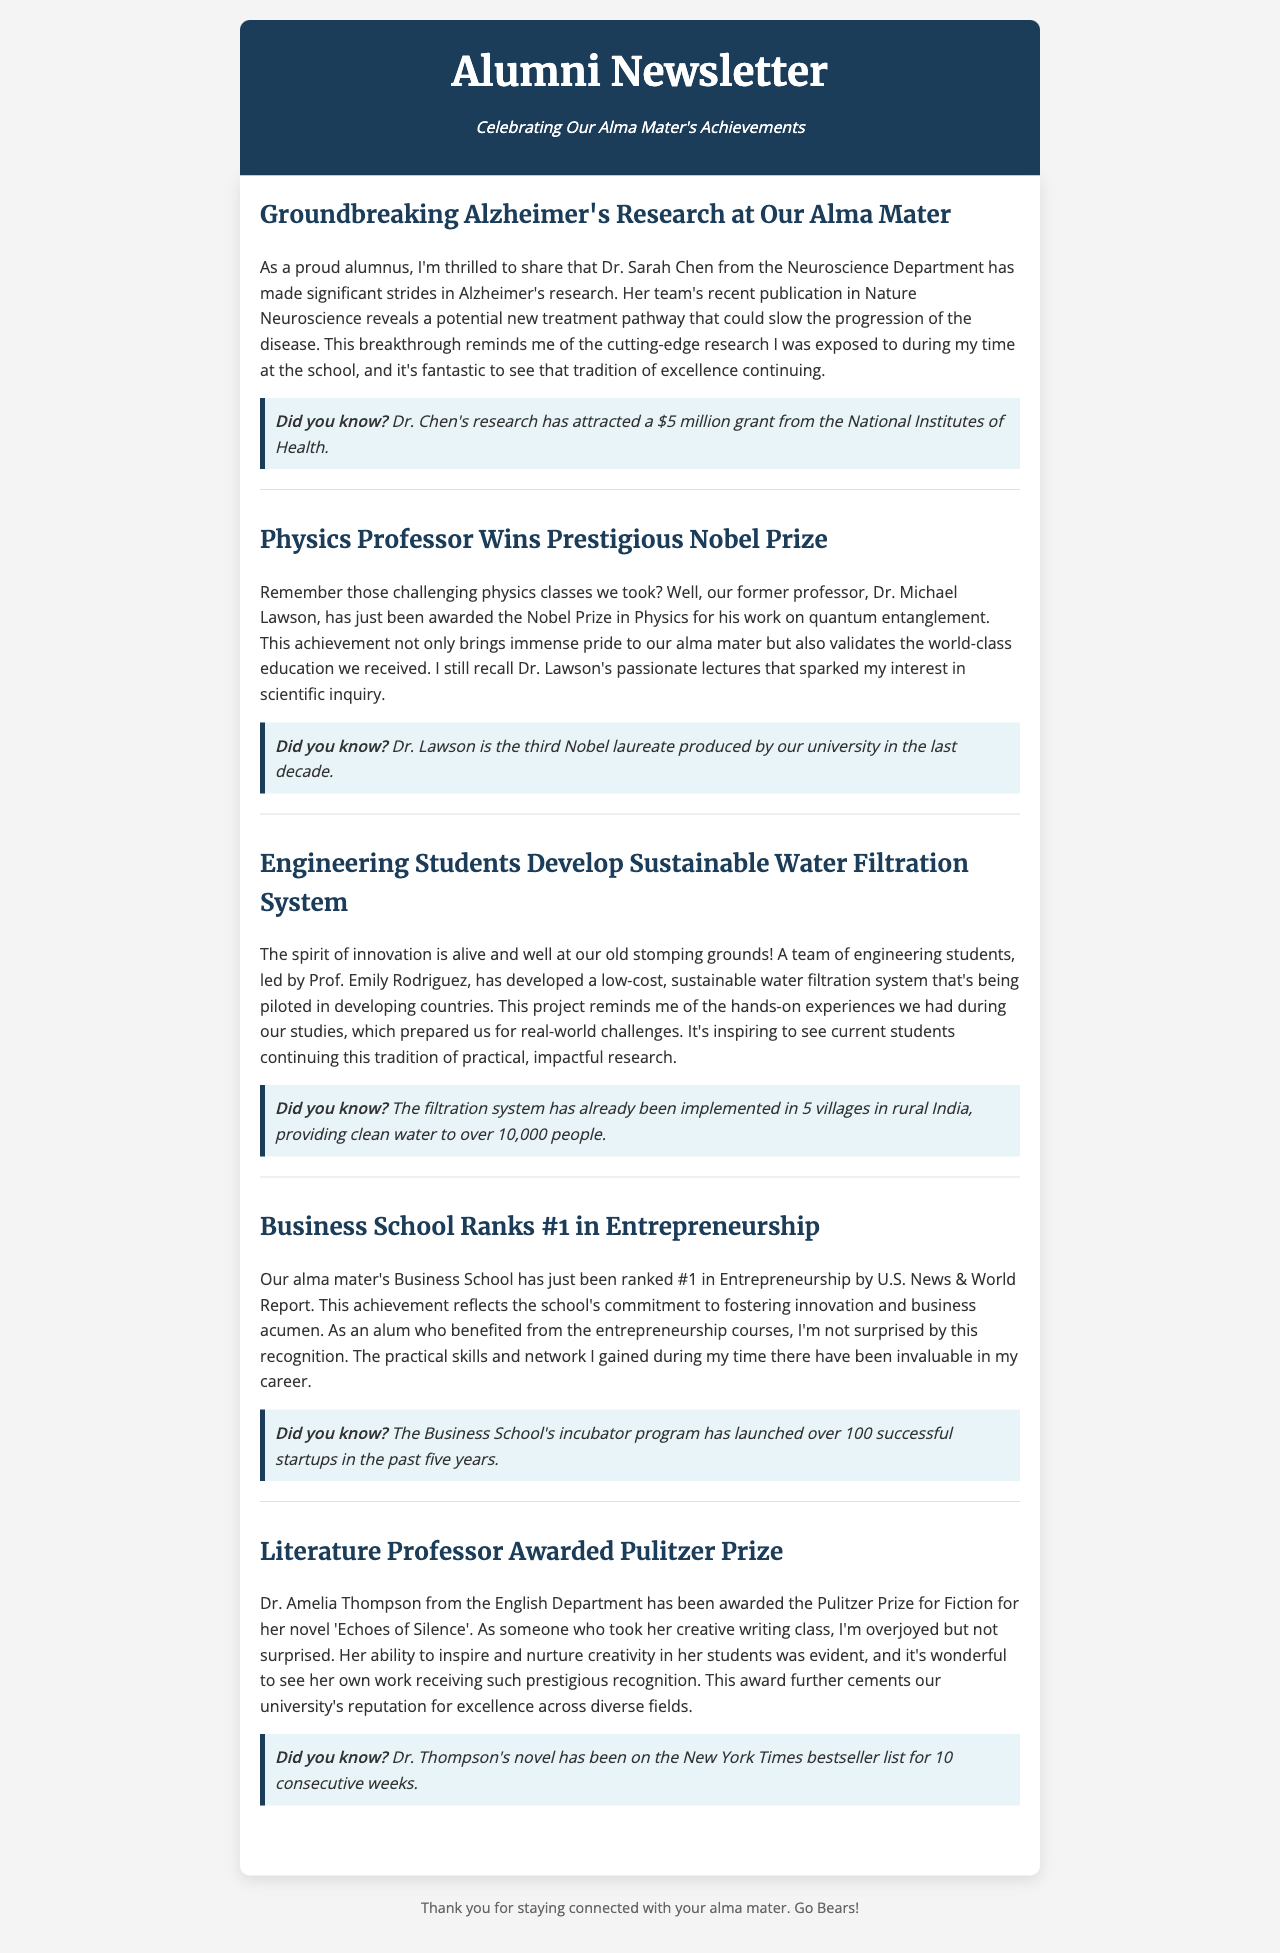What major breakthrough did Dr. Sarah Chen's team achieve? Dr. Sarah Chen's team's publication reveals a potential new treatment pathway for Alzheimer's.
Answer: new treatment pathway Who won the Nobel Prize in Physics? Dr. Michael Lawson has been awarded the Nobel Prize in Physics.
Answer: Dr. Michael Lawson How many successful startups has the Business School's incubator program launched? The Business School's incubator program has launched over 100 successful startups in the past five years.
Answer: over 100 What is the title of Dr. Amelia Thompson's Pulitzer Prize-winning novel? Dr. Amelia Thompson won the Pulitzer Prize for her novel titled 'Echoes of Silence'.
Answer: Echoes of Silence How much funding has Dr. Chen's research attracted? Dr. Chen's research has attracted a $5 million grant from the National Institutes of Health.
Answer: $5 million What number represents the Business School's ranking in Entrepreneurship? The Business School has been ranked #1 in Entrepreneurship by U.S. News & World Report.
Answer: #1 How many villages in rural India are benefiting from the sustainable water filtration system? The filtration system has been implemented in 5 villages in rural India.
Answer: 5 villages What is the duration of Dr. Thompson's novel on the New York Times bestseller list? Dr. Thompson's novel has been on the New York Times bestseller list for 10 consecutive weeks.
Answer: 10 consecutive weeks 